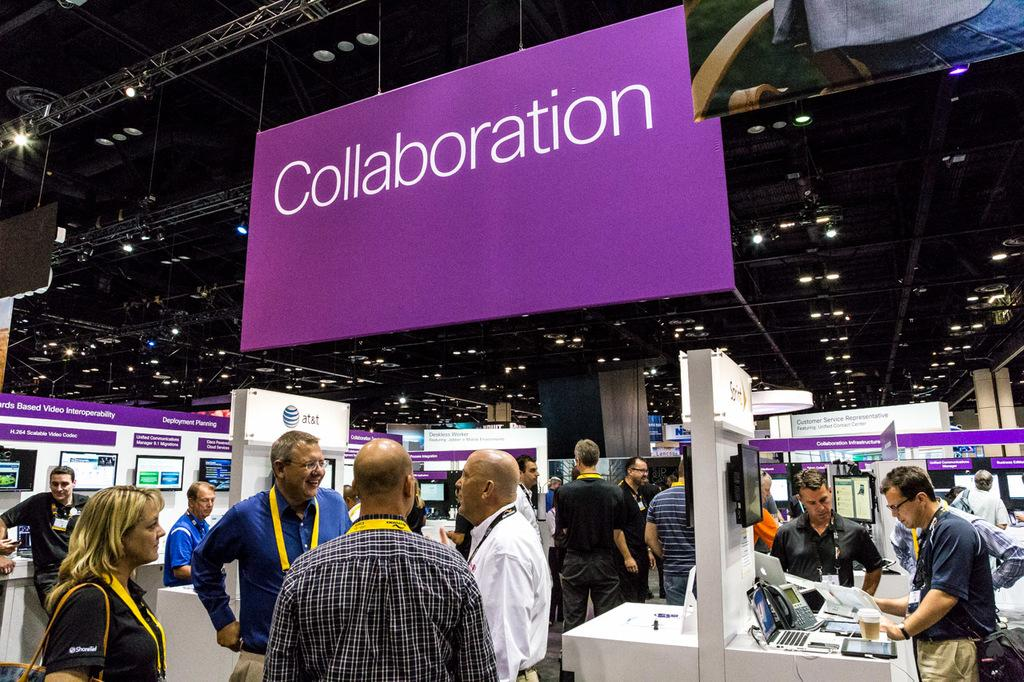<image>
Offer a succinct explanation of the picture presented. A giant collaboration sign hangs in a convention center 